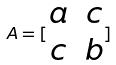<formula> <loc_0><loc_0><loc_500><loc_500>A = [ \begin{matrix} a & c \\ c & b \end{matrix} ]</formula> 